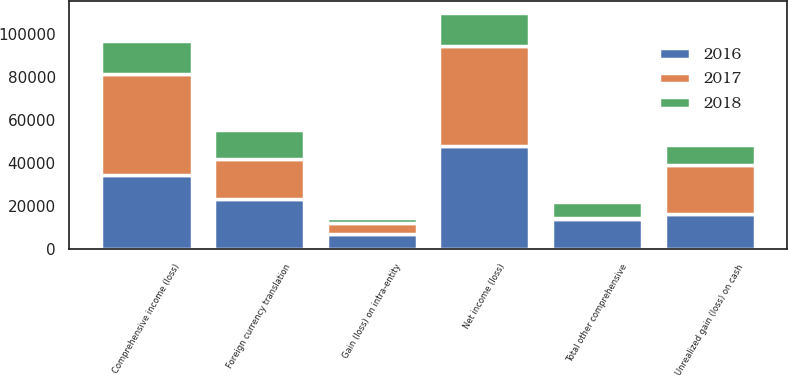Convert chart. <chart><loc_0><loc_0><loc_500><loc_500><stacked_bar_chart><ecel><fcel>Net income (loss)<fcel>Foreign currency translation<fcel>Unrealized gain (loss) on cash<fcel>Gain (loss) on intra-entity<fcel>Total other comprehensive<fcel>Comprehensive income (loss)<nl><fcel>2017<fcel>46302<fcel>18535<fcel>22800<fcel>5041<fcel>776<fcel>47078<nl><fcel>2016<fcel>48260<fcel>23357<fcel>16624<fcel>7199<fcel>13932<fcel>34328<nl><fcel>2018<fcel>15278<fcel>13798<fcel>9084<fcel>2416<fcel>7130<fcel>15278<nl></chart> 